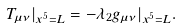Convert formula to latex. <formula><loc_0><loc_0><loc_500><loc_500>T _ { \mu \nu } | _ { x ^ { 5 } = L } = - \lambda _ { 2 } g _ { \mu \nu } | _ { x ^ { 5 } = L } .</formula> 